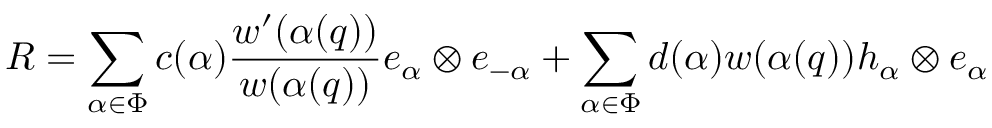<formula> <loc_0><loc_0><loc_500><loc_500>R = \sum _ { \alpha \in \Phi } c ( \alpha ) \frac { w ^ { \prime } ( \alpha ( q ) ) } { w ( \alpha ( q ) ) } e _ { \alpha } \otimes e _ { - \alpha } + \sum _ { \alpha \in \Phi } d ( \alpha ) w ( \alpha ( q ) ) h _ { \alpha } \otimes e _ { \alpha }</formula> 